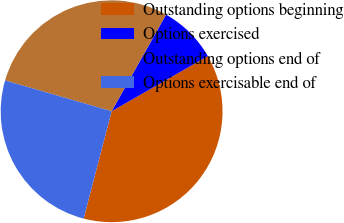Convert chart to OTSL. <chart><loc_0><loc_0><loc_500><loc_500><pie_chart><fcel>Outstanding options beginning<fcel>Options exercised<fcel>Outstanding options end of<fcel>Options exercisable end of<nl><fcel>37.34%<fcel>8.55%<fcel>28.69%<fcel>25.42%<nl></chart> 